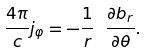Convert formula to latex. <formula><loc_0><loc_0><loc_500><loc_500>\frac { 4 \pi } { c } j _ { \varphi } = - \frac { 1 } { r } \ \frac { \partial b _ { r } } { \partial \theta } .</formula> 